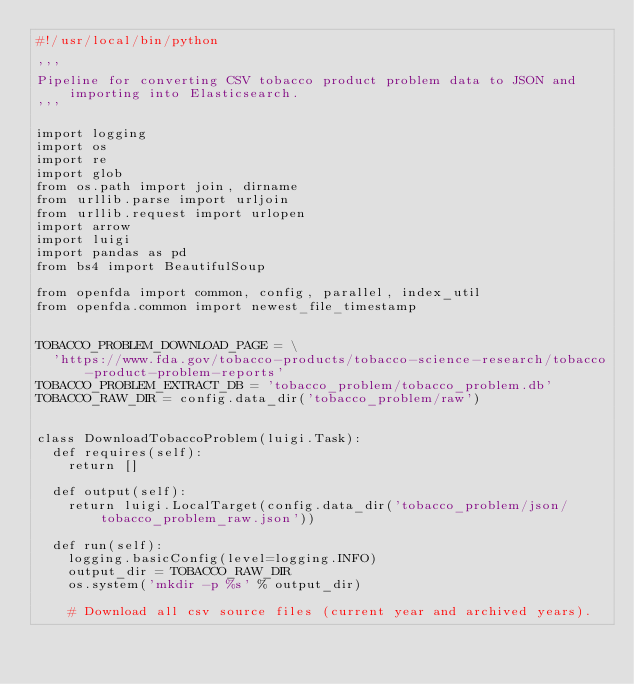Convert code to text. <code><loc_0><loc_0><loc_500><loc_500><_Python_>#!/usr/local/bin/python

'''
Pipeline for converting CSV tobacco product problem data to JSON and importing into Elasticsearch.
'''

import logging
import os
import re
import glob
from os.path import join, dirname
from urllib.parse import urljoin
from urllib.request import urlopen
import arrow
import luigi
import pandas as pd
from bs4 import BeautifulSoup

from openfda import common, config, parallel, index_util
from openfda.common import newest_file_timestamp


TOBACCO_PROBLEM_DOWNLOAD_PAGE = \
  'https://www.fda.gov/tobacco-products/tobacco-science-research/tobacco-product-problem-reports'
TOBACCO_PROBLEM_EXTRACT_DB = 'tobacco_problem/tobacco_problem.db'
TOBACCO_RAW_DIR = config.data_dir('tobacco_problem/raw')


class DownloadTobaccoProblem(luigi.Task):
  def requires(self):
    return []

  def output(self):
    return luigi.LocalTarget(config.data_dir('tobacco_problem/json/tobacco_problem_raw.json'))

  def run(self):
    logging.basicConfig(level=logging.INFO)
    output_dir = TOBACCO_RAW_DIR
    os.system('mkdir -p %s' % output_dir)

    # Download all csv source files (current year and archived years).</code> 